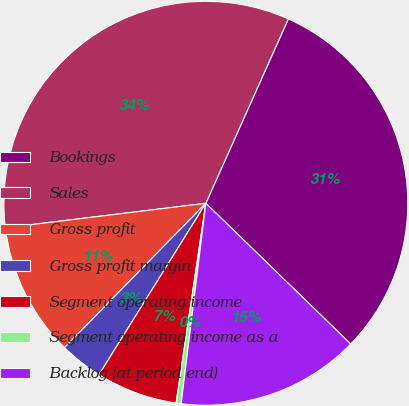Convert chart. <chart><loc_0><loc_0><loc_500><loc_500><pie_chart><fcel>Bookings<fcel>Sales<fcel>Gross profit<fcel>Gross profit margin<fcel>Segment operating income<fcel>Segment operating income as a<fcel>Backlog (at period end)<nl><fcel>30.57%<fcel>33.63%<fcel>10.73%<fcel>3.46%<fcel>6.52%<fcel>0.4%<fcel>14.68%<nl></chart> 